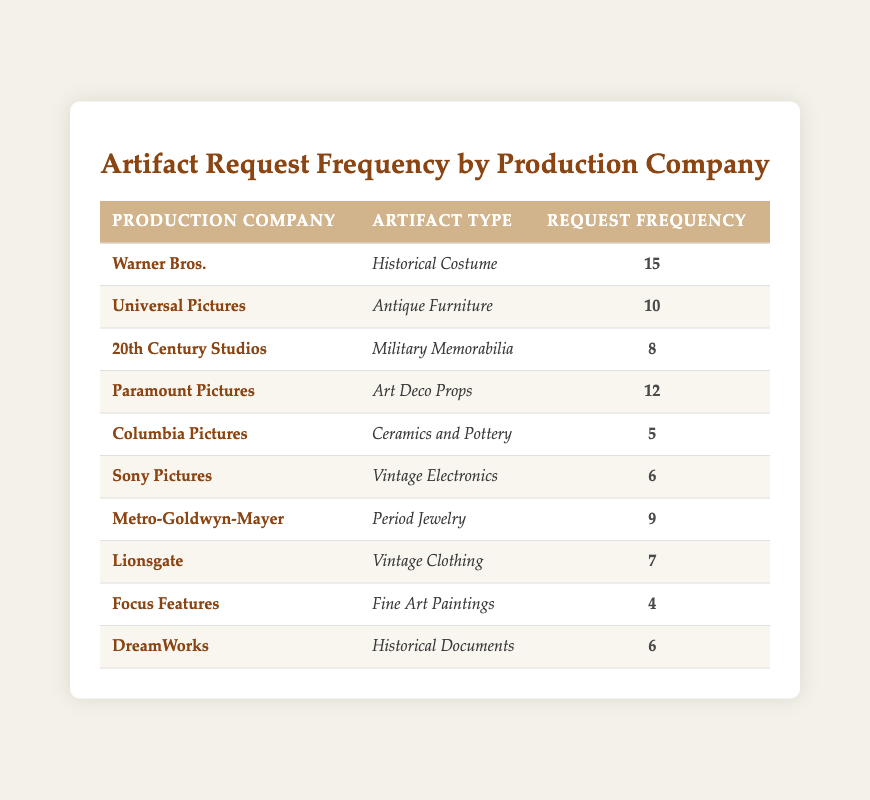What is the highest request frequency for artifacts? By checking the "Request Frequency" column, we see that Warner Bros. has the highest request frequency of 15.
Answer: 15 Which production company requested Period Jewelry? Looking at the "Artifact Type" column for Period Jewelry, we find that it is associated with Metro-Goldwyn-Mayer.
Answer: Metro-Goldwyn-Mayer What is the total request frequency for all artifacts? We sum all the request frequencies: 15 + 10 + 8 + 12 + 5 + 6 + 9 + 7 + 4 + 6 = 82.
Answer: 82 How many production companies requested more than 6 artifacts? We can identify the companies with request frequencies greater than 6: Warner Bros. (15), Universal Pictures (10), Paramount Pictures (12), Metro-Goldwyn-Mayer (9), and Lionsgate (7), which gives us a total of 5 production companies.
Answer: 5 Is there any production company that requested Fine Art Paintings? Checking the "Artifact Type" column, Focus Features is the company that requested Fine Art Paintings, resulting in a yes.
Answer: Yes What is the request frequency difference between Warner Bros. and Columbia Pictures? Warner Bros. has a frequency of 15, and Columbia Pictures has a frequency of 5. The difference is calculated as 15 - 5 = 10.
Answer: 10 What is the average request frequency across all production companies? First, we sum the request frequencies (82) and divide by the number of production companies, which is 10: 82 / 10 = 8.2.
Answer: 8.2 Which artifact type was least requested based on the data? Checking the request frequencies, Fine Art Paintings requested by Focus Features has the lowest frequency of 4.
Answer: Fine Art Paintings How many total requests were made by Universal Pictures and 20th Century Studios combined? Universal Pictures has 10 requests, while 20th Century Studios has 8. Adding these together gives us 10 + 8 = 18.
Answer: 18 Which artifact type has the highest request frequency from the table? The highest demand is for Historical Costumes, requested 15 times by Warner Bros.
Answer: Historical Costume 